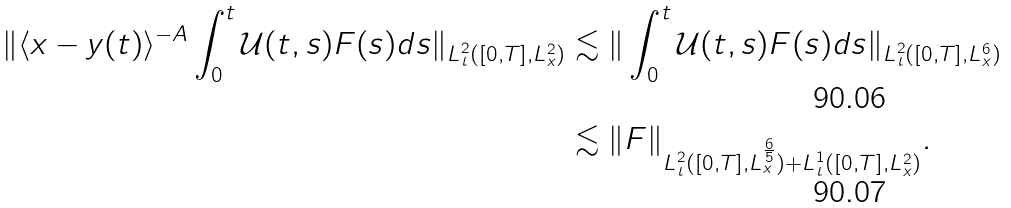<formula> <loc_0><loc_0><loc_500><loc_500>\| \langle x - y ( t ) \rangle ^ { - A } \int _ { 0 } ^ { t } \mathcal { U } ( t , s ) F ( s ) d s \| _ { L ^ { 2 } _ { t } ( [ 0 , T ] , L ^ { 2 } _ { x } ) } & \lesssim \| \int _ { 0 } ^ { t } \mathcal { U } ( t , s ) F ( s ) d s \| _ { L ^ { 2 } _ { t } ( [ 0 , T ] , L ^ { 6 } _ { x } ) } \\ & \lesssim \| F \| _ { L ^ { 2 } _ { t } ( [ 0 , T ] , L ^ { \frac { 6 } { 5 } } _ { x } ) + L ^ { 1 } _ { t } ( [ 0 , T ] , L ^ { 2 } _ { x } ) } .</formula> 